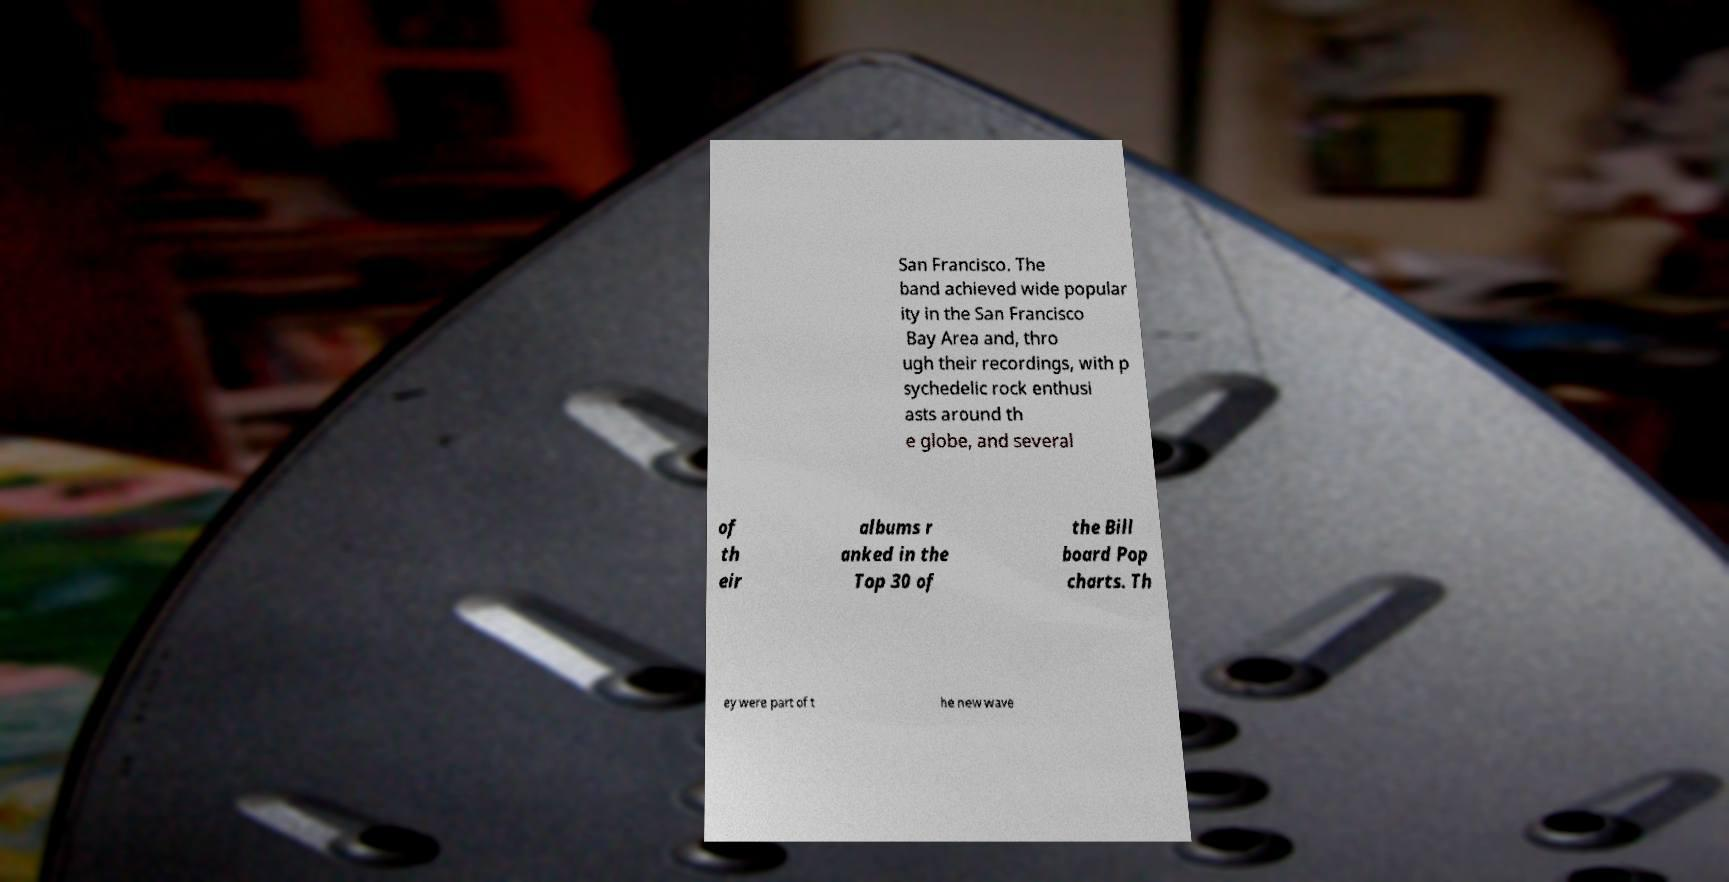I need the written content from this picture converted into text. Can you do that? San Francisco. The band achieved wide popular ity in the San Francisco Bay Area and, thro ugh their recordings, with p sychedelic rock enthusi asts around th e globe, and several of th eir albums r anked in the Top 30 of the Bill board Pop charts. Th ey were part of t he new wave 